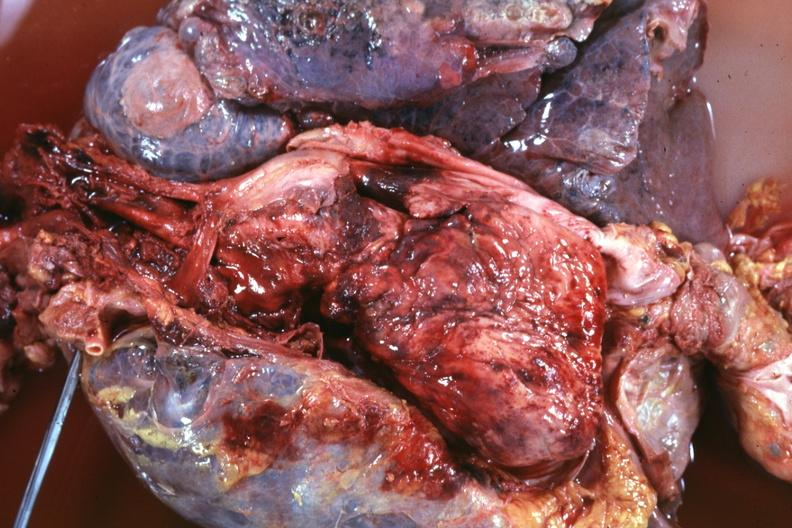s fibrinous peritonitis present?
Answer the question using a single word or phrase. No 